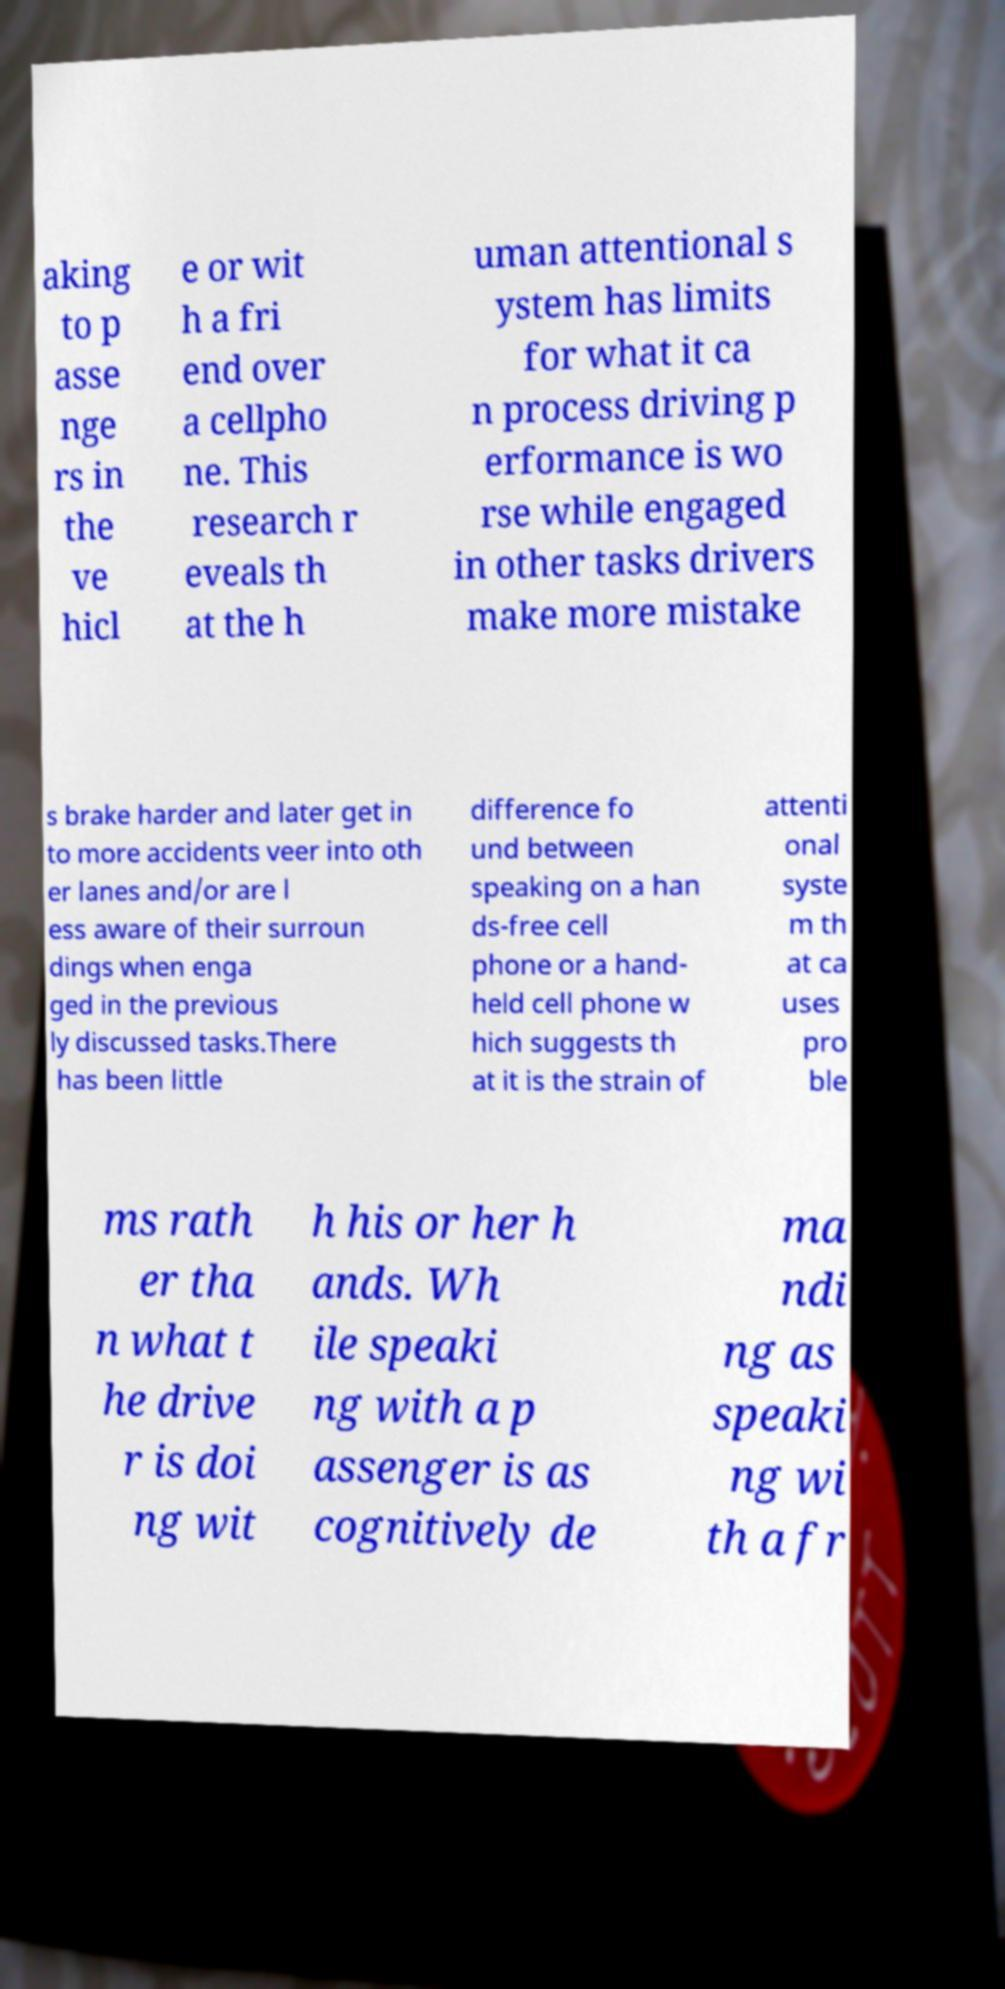Please read and relay the text visible in this image. What does it say? aking to p asse nge rs in the ve hicl e or wit h a fri end over a cellpho ne. This research r eveals th at the h uman attentional s ystem has limits for what it ca n process driving p erformance is wo rse while engaged in other tasks drivers make more mistake s brake harder and later get in to more accidents veer into oth er lanes and/or are l ess aware of their surroun dings when enga ged in the previous ly discussed tasks.There has been little difference fo und between speaking on a han ds-free cell phone or a hand- held cell phone w hich suggests th at it is the strain of attenti onal syste m th at ca uses pro ble ms rath er tha n what t he drive r is doi ng wit h his or her h ands. Wh ile speaki ng with a p assenger is as cognitively de ma ndi ng as speaki ng wi th a fr 